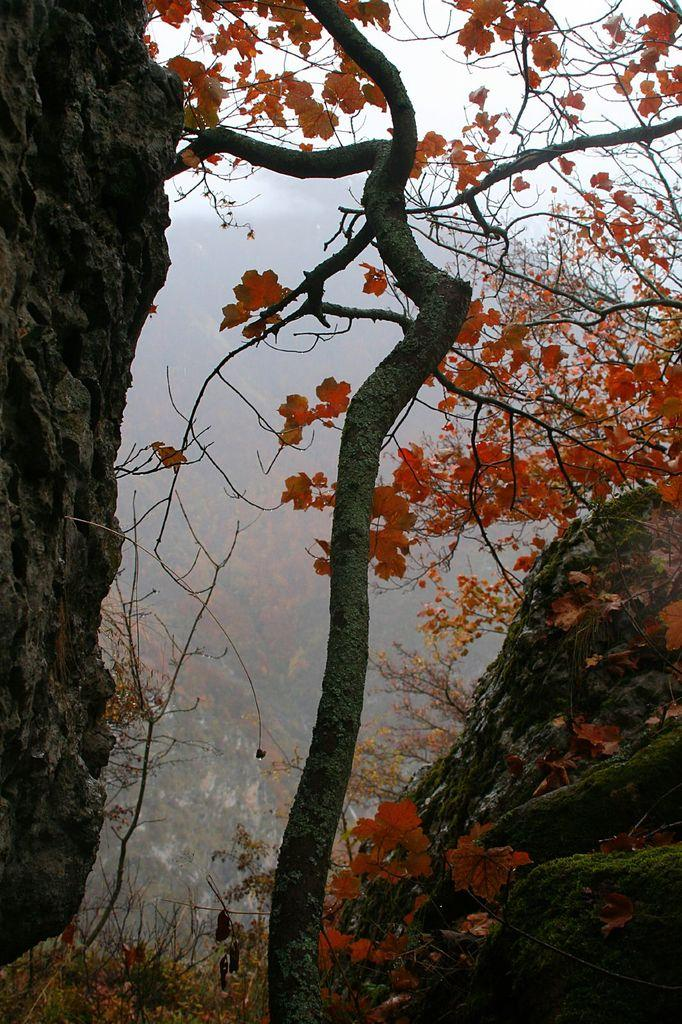What type of vegetation can be seen in the image? There are trees in the image. What type of pleasure can be derived from the trees in the image? The image does not convey any information about the pleasure that can be derived from the trees; it only shows their presence. 